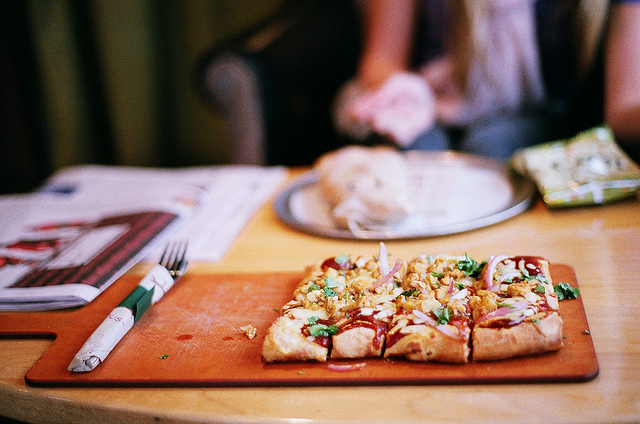<image>Why does the platter have a long handle? I don't know why the platter has a long handle. It can be for taking pizza out of hot oven or make it easier to grip. Why does the platter have a long handle? I don't know why the platter has a long handle. It can be used to get pizza out of a hot oven or to carry food. 